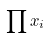<formula> <loc_0><loc_0><loc_500><loc_500>\prod x _ { i }</formula> 